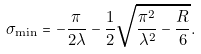Convert formula to latex. <formula><loc_0><loc_0><loc_500><loc_500>\sigma _ { \min } = - \frac { \pi } { 2 \lambda } - \frac { 1 } { 2 } \sqrt { \frac { \pi ^ { 2 } } { \lambda ^ { 2 } } - \frac { R } { 6 } } .</formula> 